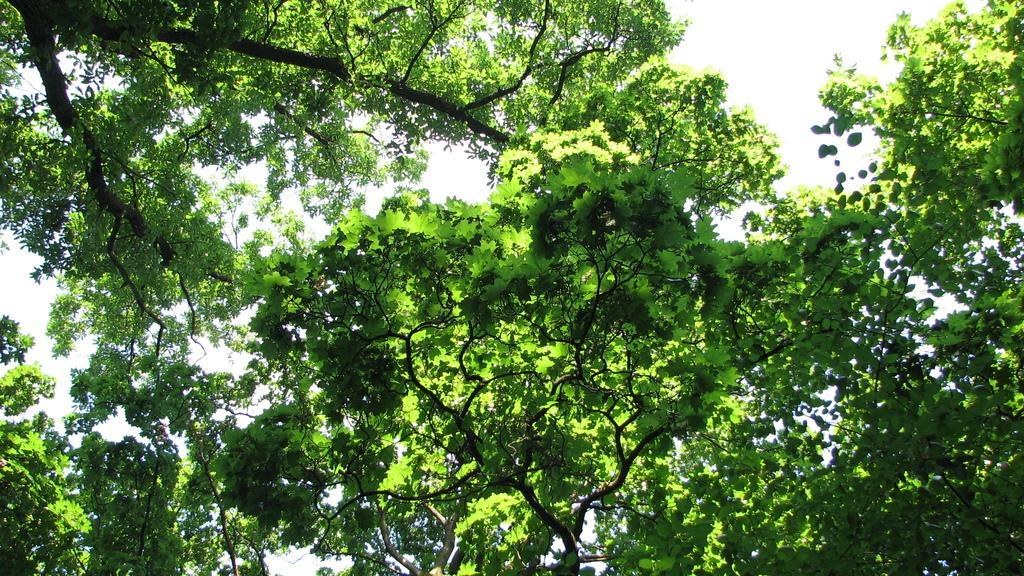Describe this image in one or two sentences. In this image there are trees. Background there is sky. 